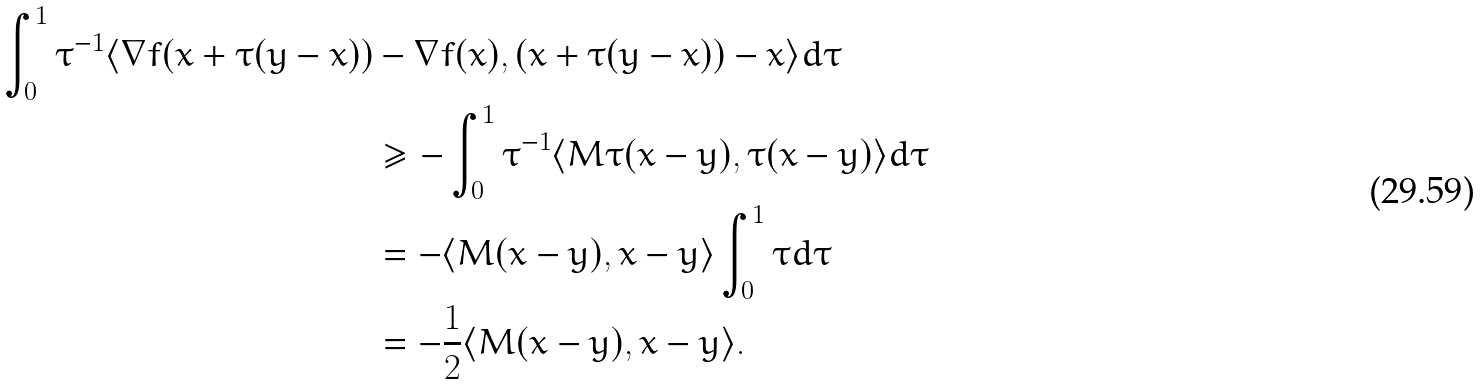Convert formula to latex. <formula><loc_0><loc_0><loc_500><loc_500>\int _ { 0 } ^ { 1 } \tau ^ { - 1 } \langle \nabla f ( x + \tau ( y - x ) ) & - \nabla f ( x ) , ( x + \tau ( y - x ) ) - x \rangle d \tau \\ & \geq - \int _ { 0 } ^ { 1 } \tau ^ { - 1 } \langle M \tau ( x - y ) , \tau ( x - y ) \rangle d \tau \\ & = - \langle M ( x - y ) , x - y \rangle \int _ { 0 } ^ { 1 } \tau d \tau \\ & = - \frac { 1 } { 2 } \langle M ( x - y ) , x - y \rangle .</formula> 